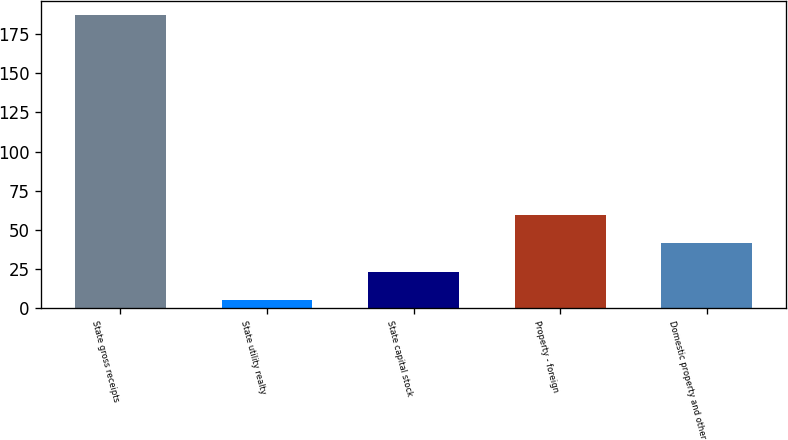Convert chart to OTSL. <chart><loc_0><loc_0><loc_500><loc_500><bar_chart><fcel>State gross receipts<fcel>State utility realty<fcel>State capital stock<fcel>Property - foreign<fcel>Domestic property and other<nl><fcel>187<fcel>5<fcel>23.2<fcel>59.6<fcel>41.4<nl></chart> 